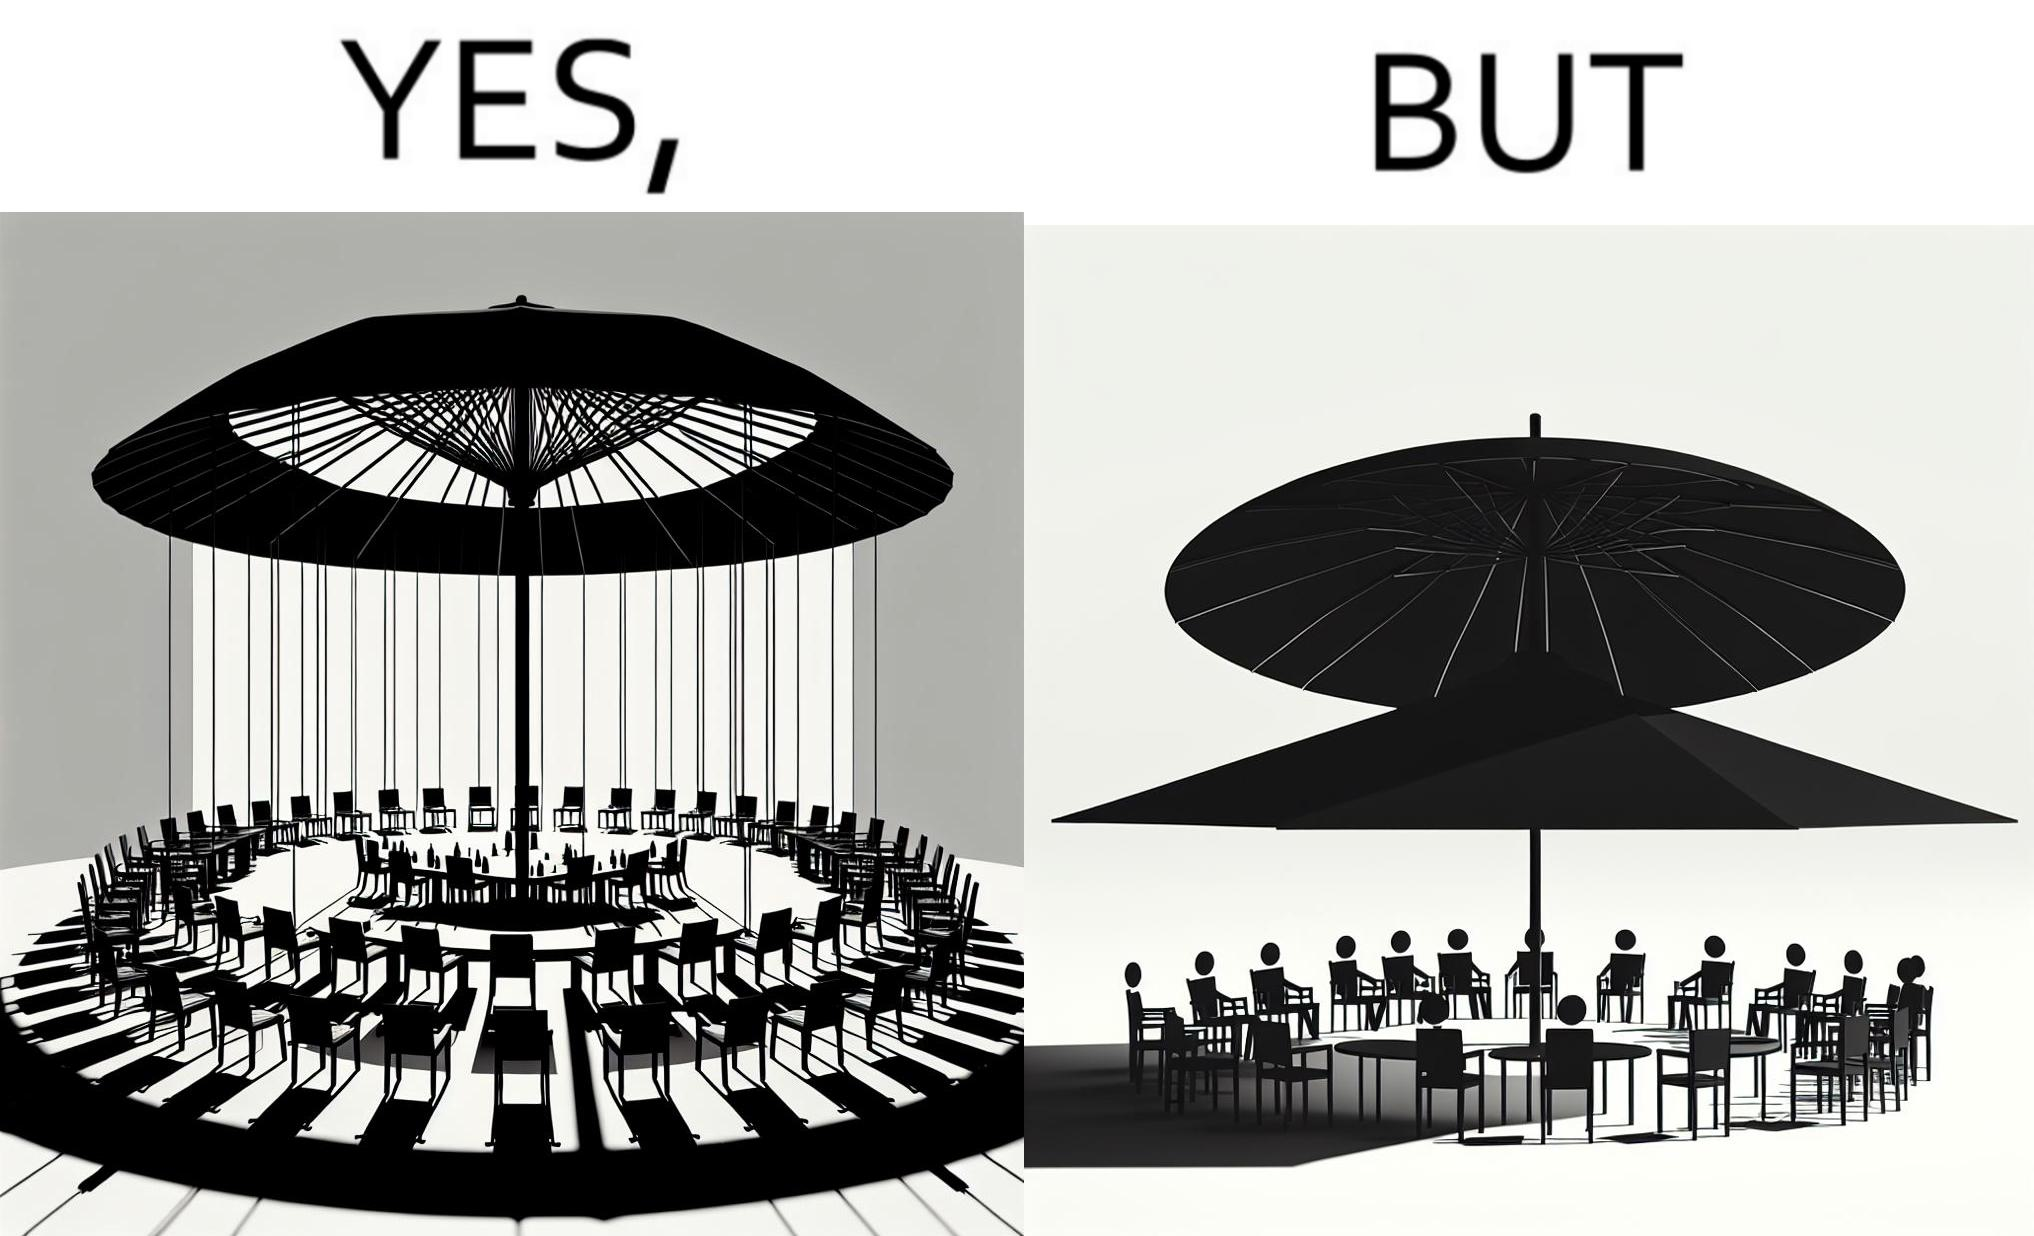Describe what you see in this image. The image is ironical, as the umbrella is meant to provide shadow in the area where the chairs are present, but due to the orientation of the rays of the sun, all the chairs are in sunlight, and the umbrella is of no use in this situation. 